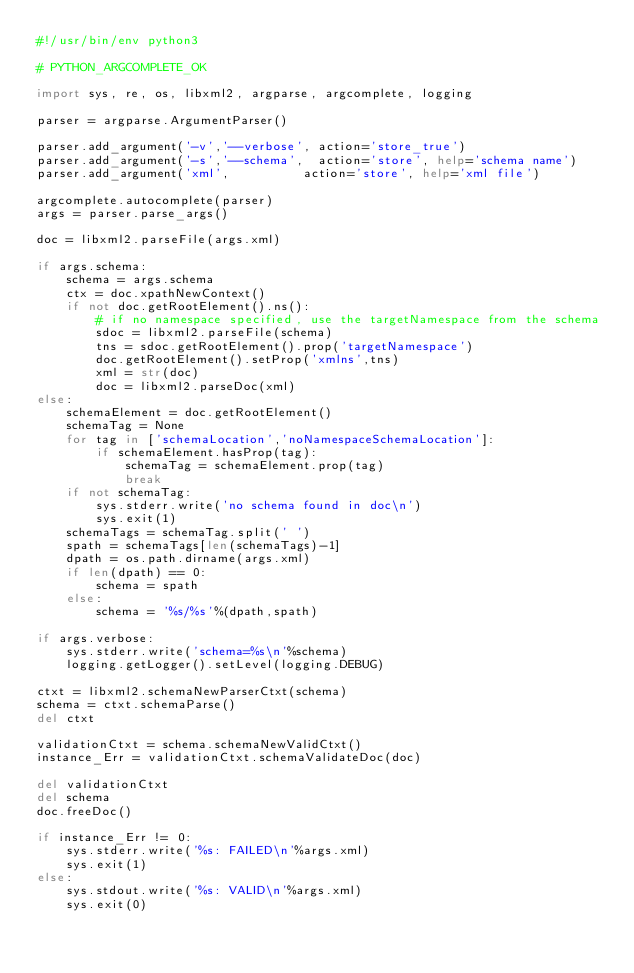<code> <loc_0><loc_0><loc_500><loc_500><_Python_>#!/usr/bin/env python3

# PYTHON_ARGCOMPLETE_OK

import sys, re, os, libxml2, argparse, argcomplete, logging

parser = argparse.ArgumentParser()

parser.add_argument('-v','--verbose', action='store_true')
parser.add_argument('-s','--schema',  action='store', help='schema name')
parser.add_argument('xml',			action='store', help='xml file')

argcomplete.autocomplete(parser)
args = parser.parse_args()

doc = libxml2.parseFile(args.xml)

if args.schema:
	schema = args.schema
	ctx = doc.xpathNewContext()
	if not doc.getRootElement().ns():
		# if no namespace specified, use the targetNamespace from the schema
		sdoc = libxml2.parseFile(schema)
		tns = sdoc.getRootElement().prop('targetNamespace')
		doc.getRootElement().setProp('xmlns',tns)
		xml = str(doc)
		doc = libxml2.parseDoc(xml)
else:
	schemaElement = doc.getRootElement()
	schemaTag = None
	for tag in ['schemaLocation','noNamespaceSchemaLocation']:
		if schemaElement.hasProp(tag):
			schemaTag = schemaElement.prop(tag)
			break
	if not schemaTag:
		sys.stderr.write('no schema found in doc\n')
		sys.exit(1)
	schemaTags = schemaTag.split(' ')
	spath = schemaTags[len(schemaTags)-1]
	dpath = os.path.dirname(args.xml)
	if len(dpath) == 0:
		schema = spath
	else:
		schema = '%s/%s'%(dpath,spath)

if args.verbose:
	sys.stderr.write('schema=%s\n'%schema)
	logging.getLogger().setLevel(logging.DEBUG)

ctxt = libxml2.schemaNewParserCtxt(schema)
schema = ctxt.schemaParse()
del ctxt

validationCtxt = schema.schemaNewValidCtxt()
instance_Err = validationCtxt.schemaValidateDoc(doc)

del validationCtxt
del schema
doc.freeDoc()

if instance_Err != 0:
	sys.stderr.write('%s: FAILED\n'%args.xml)
	sys.exit(1)
else:
	sys.stdout.write('%s: VALID\n'%args.xml)
	sys.exit(0)
</code> 